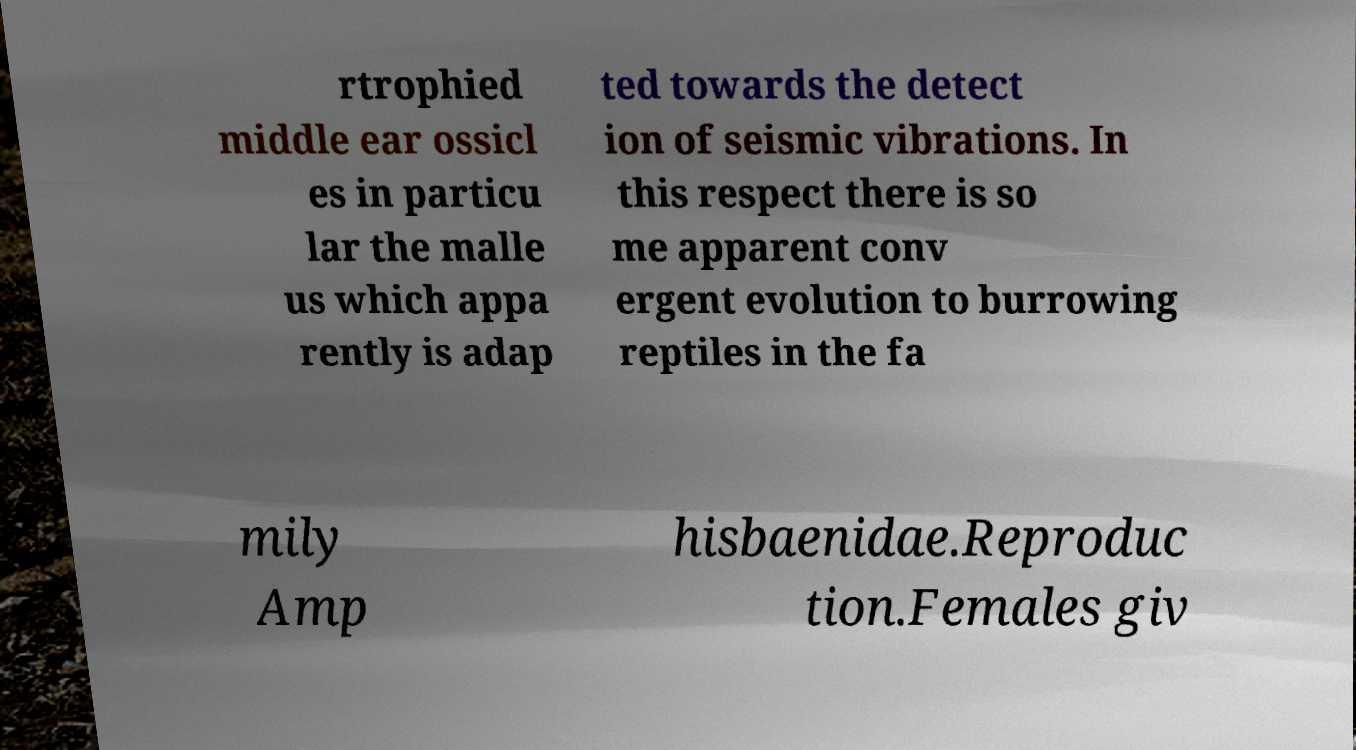What messages or text are displayed in this image? I need them in a readable, typed format. rtrophied middle ear ossicl es in particu lar the malle us which appa rently is adap ted towards the detect ion of seismic vibrations. In this respect there is so me apparent conv ergent evolution to burrowing reptiles in the fa mily Amp hisbaenidae.Reproduc tion.Females giv 